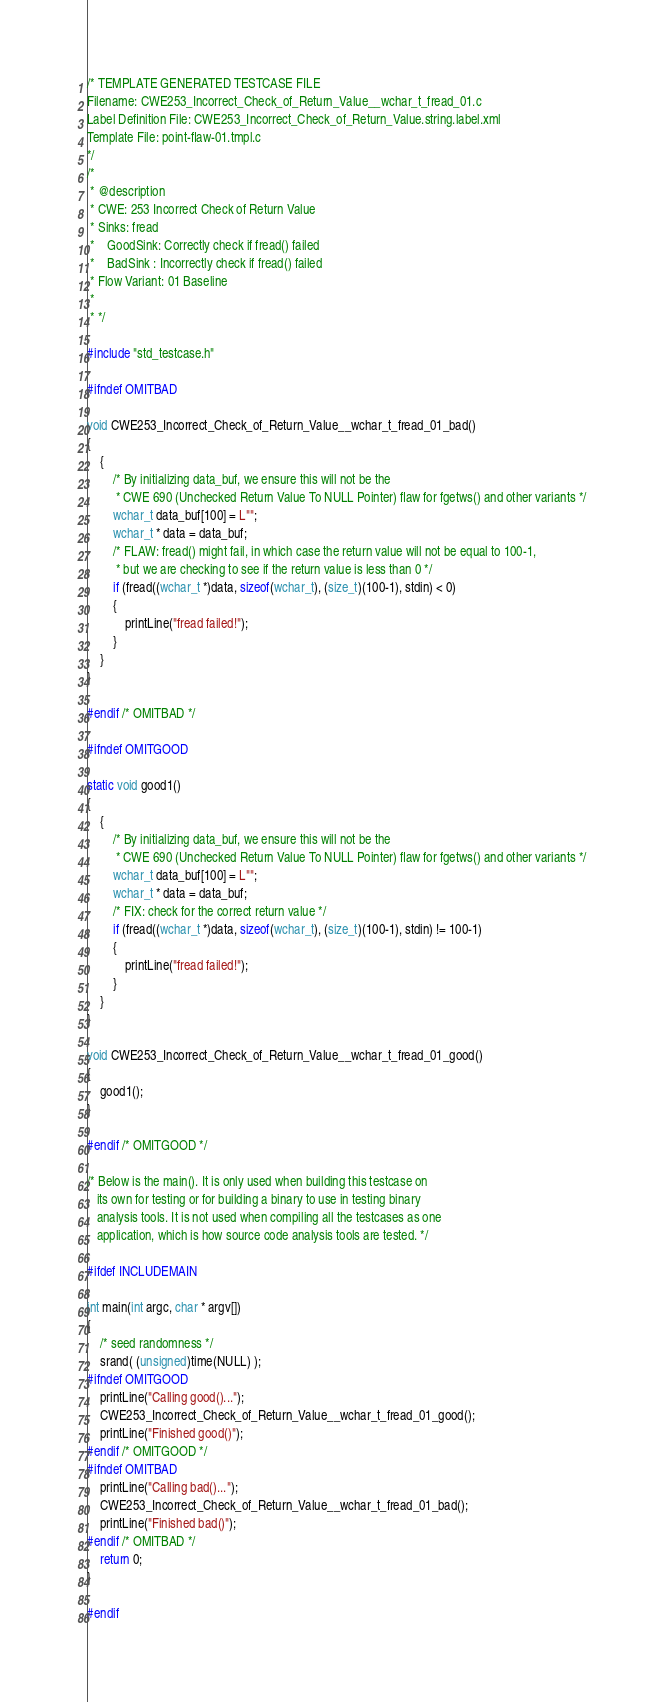<code> <loc_0><loc_0><loc_500><loc_500><_C_>/* TEMPLATE GENERATED TESTCASE FILE
Filename: CWE253_Incorrect_Check_of_Return_Value__wchar_t_fread_01.c
Label Definition File: CWE253_Incorrect_Check_of_Return_Value.string.label.xml
Template File: point-flaw-01.tmpl.c
*/
/*
 * @description
 * CWE: 253 Incorrect Check of Return Value
 * Sinks: fread
 *    GoodSink: Correctly check if fread() failed
 *    BadSink : Incorrectly check if fread() failed
 * Flow Variant: 01 Baseline
 *
 * */

#include "std_testcase.h"

#ifndef OMITBAD

void CWE253_Incorrect_Check_of_Return_Value__wchar_t_fread_01_bad()
{
    {
        /* By initializing data_buf, we ensure this will not be the
         * CWE 690 (Unchecked Return Value To NULL Pointer) flaw for fgetws() and other variants */
        wchar_t data_buf[100] = L"";
        wchar_t * data = data_buf;
        /* FLAW: fread() might fail, in which case the return value will not be equal to 100-1,
         * but we are checking to see if the return value is less than 0 */
        if (fread((wchar_t *)data, sizeof(wchar_t), (size_t)(100-1), stdin) < 0)
        {
            printLine("fread failed!");
        }
    }
}

#endif /* OMITBAD */

#ifndef OMITGOOD

static void good1()
{
    {
        /* By initializing data_buf, we ensure this will not be the
         * CWE 690 (Unchecked Return Value To NULL Pointer) flaw for fgetws() and other variants */
        wchar_t data_buf[100] = L"";
        wchar_t * data = data_buf;
        /* FIX: check for the correct return value */
        if (fread((wchar_t *)data, sizeof(wchar_t), (size_t)(100-1), stdin) != 100-1)
        {
            printLine("fread failed!");
        }
    }
}

void CWE253_Incorrect_Check_of_Return_Value__wchar_t_fread_01_good()
{
    good1();
}

#endif /* OMITGOOD */

/* Below is the main(). It is only used when building this testcase on
   its own for testing or for building a binary to use in testing binary
   analysis tools. It is not used when compiling all the testcases as one
   application, which is how source code analysis tools are tested. */

#ifdef INCLUDEMAIN

int main(int argc, char * argv[])
{
    /* seed randomness */
    srand( (unsigned)time(NULL) );
#ifndef OMITGOOD
    printLine("Calling good()...");
    CWE253_Incorrect_Check_of_Return_Value__wchar_t_fread_01_good();
    printLine("Finished good()");
#endif /* OMITGOOD */
#ifndef OMITBAD
    printLine("Calling bad()...");
    CWE253_Incorrect_Check_of_Return_Value__wchar_t_fread_01_bad();
    printLine("Finished bad()");
#endif /* OMITBAD */
    return 0;
}

#endif
</code> 